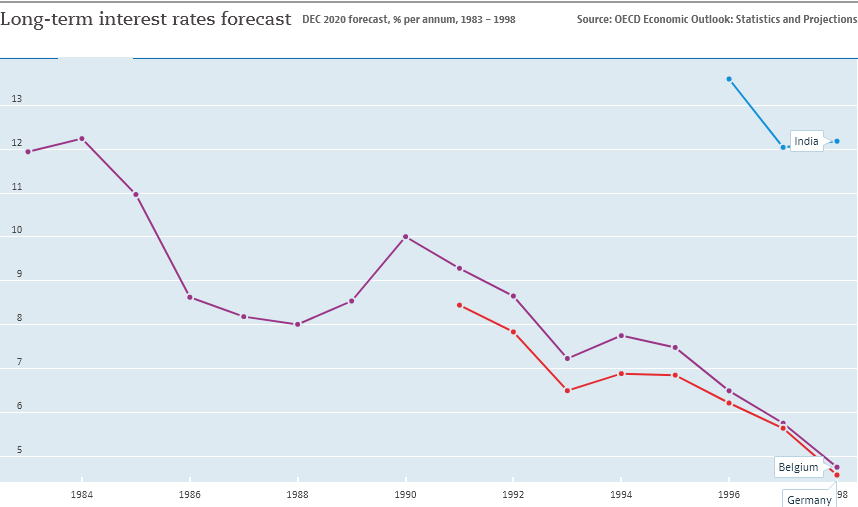Specify some key components in this picture. There are three colors depicted in the bar graph. The highest value and lowest value of Belgium are 7.4. 